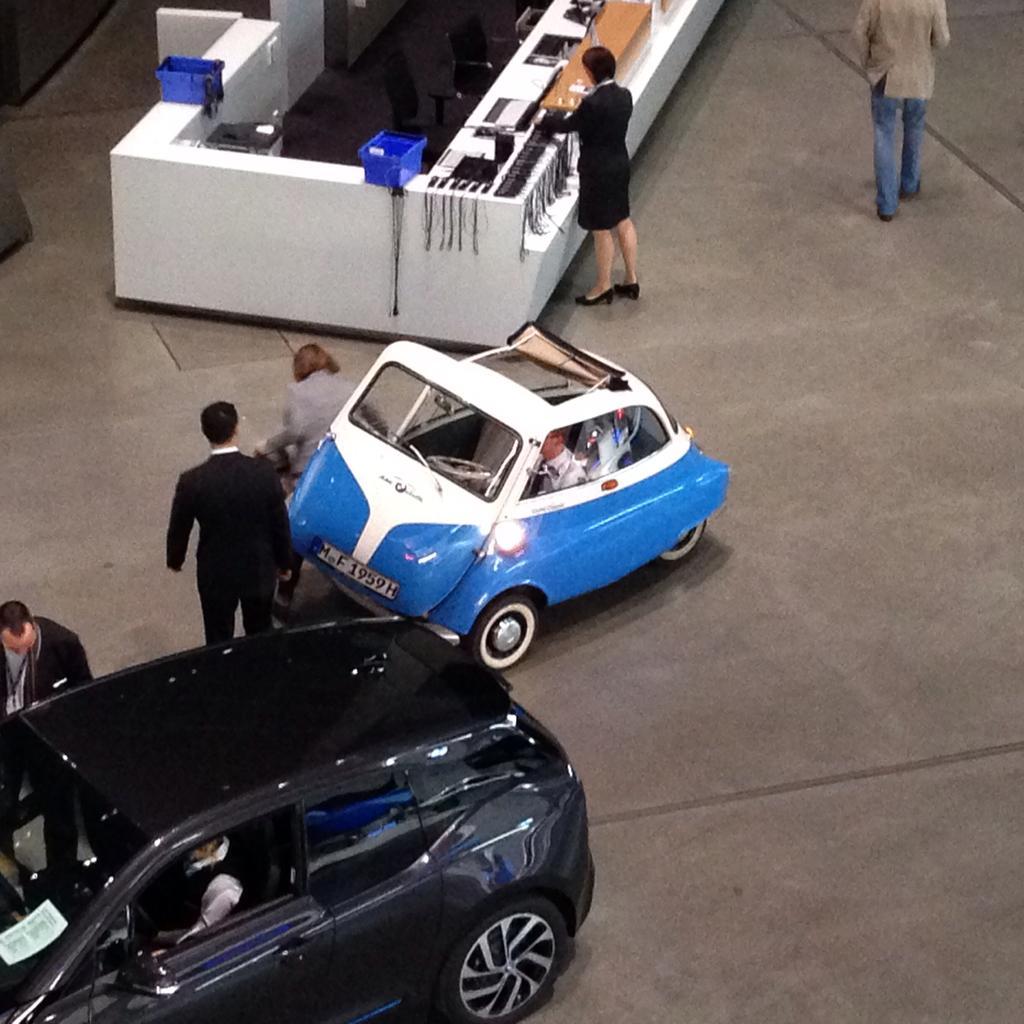Please provide a concise description of this image. This is a picture taken in a room, on the floor there is a black car and the man riding the car and there is other car in blue and white color. Background of the car is a reception and the woman in black dress standing on the floor. 